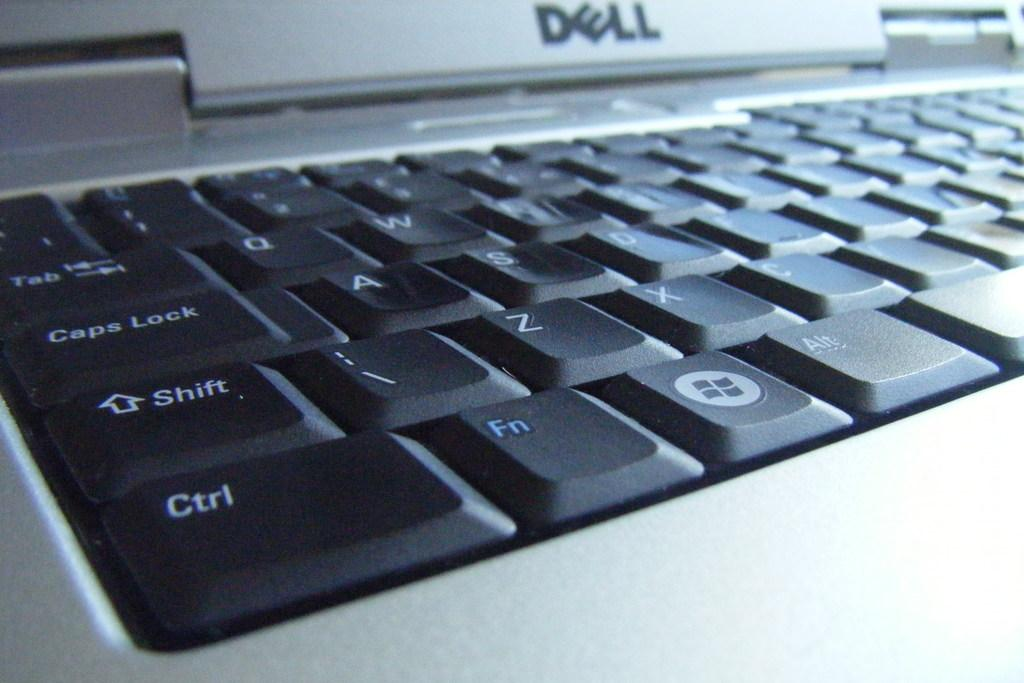<image>
Share a concise interpretation of the image provided. A closeup of the keyboard on a Dell laptop is shown. 